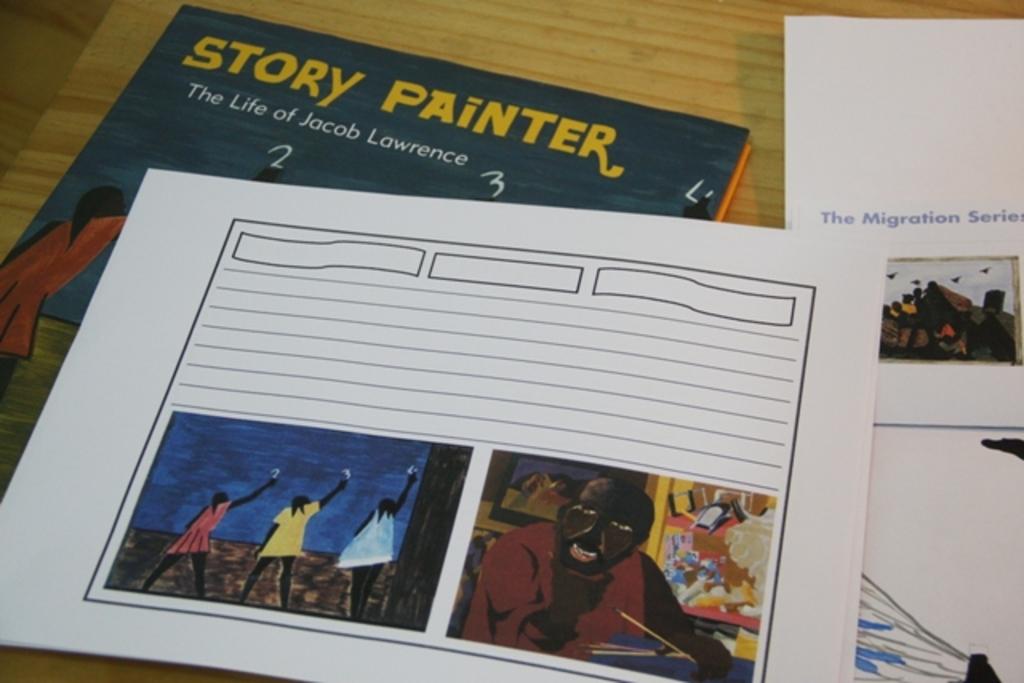What person is that book about?
Provide a short and direct response. Jacob lawrence. 